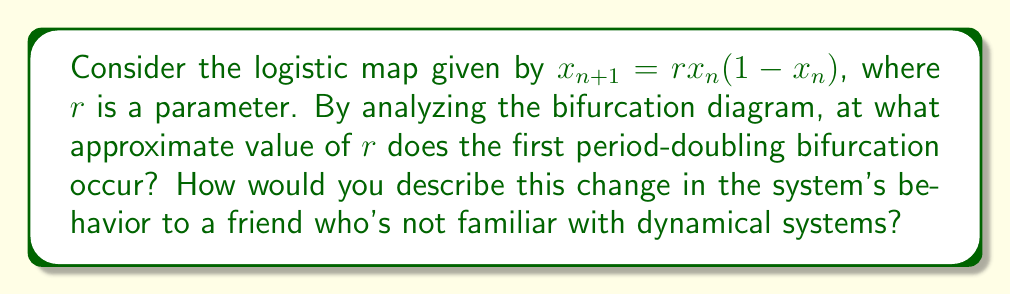Solve this math problem. Let's break this down step-by-step:

1) The logistic map is defined by the equation $x_{n+1} = rx_n(1-x_n)$, where $r$ is a parameter that controls the behavior of the system.

2) To understand the bifurcation diagram, we need to iterate this map for different values of $r$ and observe the long-term behavior of $x_n$.

3) For small values of $r$ (0 < $r$ < 1), the system converges to 0.

4) As $r$ increases beyond 1, the system converges to a single non-zero fixed point.

5) The first period-doubling bifurcation occurs when this single fixed point splits into two points that the system alternates between.

6) This first bifurcation happens at approximately $r = 3$.

7) To explain this to a friend unfamiliar with dynamical systems, you could say:
   "Imagine a population that grows and shrinks each year. At first, it settles to a steady size. But when conditions change (represented by increasing $r$), it starts to alternate between two different sizes each year, like a two-year cycle. This switch from steady to alternating is what we call the first period-doubling bifurcation."

8) As $r$ continues to increase, more period-doubling bifurcations occur, leading to cycles of 4, 8, 16, and so on, eventually resulting in chaos.
Answer: $r \approx 3$ 